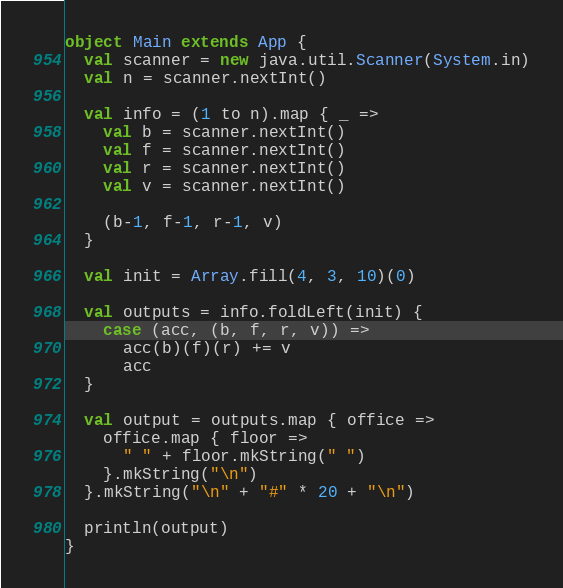Convert code to text. <code><loc_0><loc_0><loc_500><loc_500><_Scala_>object Main extends App {
  val scanner = new java.util.Scanner(System.in)
  val n = scanner.nextInt()

  val info = (1 to n).map { _ =>
    val b = scanner.nextInt()
    val f = scanner.nextInt()
    val r = scanner.nextInt()
    val v = scanner.nextInt()

    (b-1, f-1, r-1, v)
  }

  val init = Array.fill(4, 3, 10)(0)

  val outputs = info.foldLeft(init) {
    case (acc, (b, f, r, v)) =>
      acc(b)(f)(r) += v
      acc
  }

  val output = outputs.map { office =>
    office.map { floor => 
      " " + floor.mkString(" ")
    }.mkString("\n")
  }.mkString("\n" + "#" * 20 + "\n")

  println(output)
}</code> 